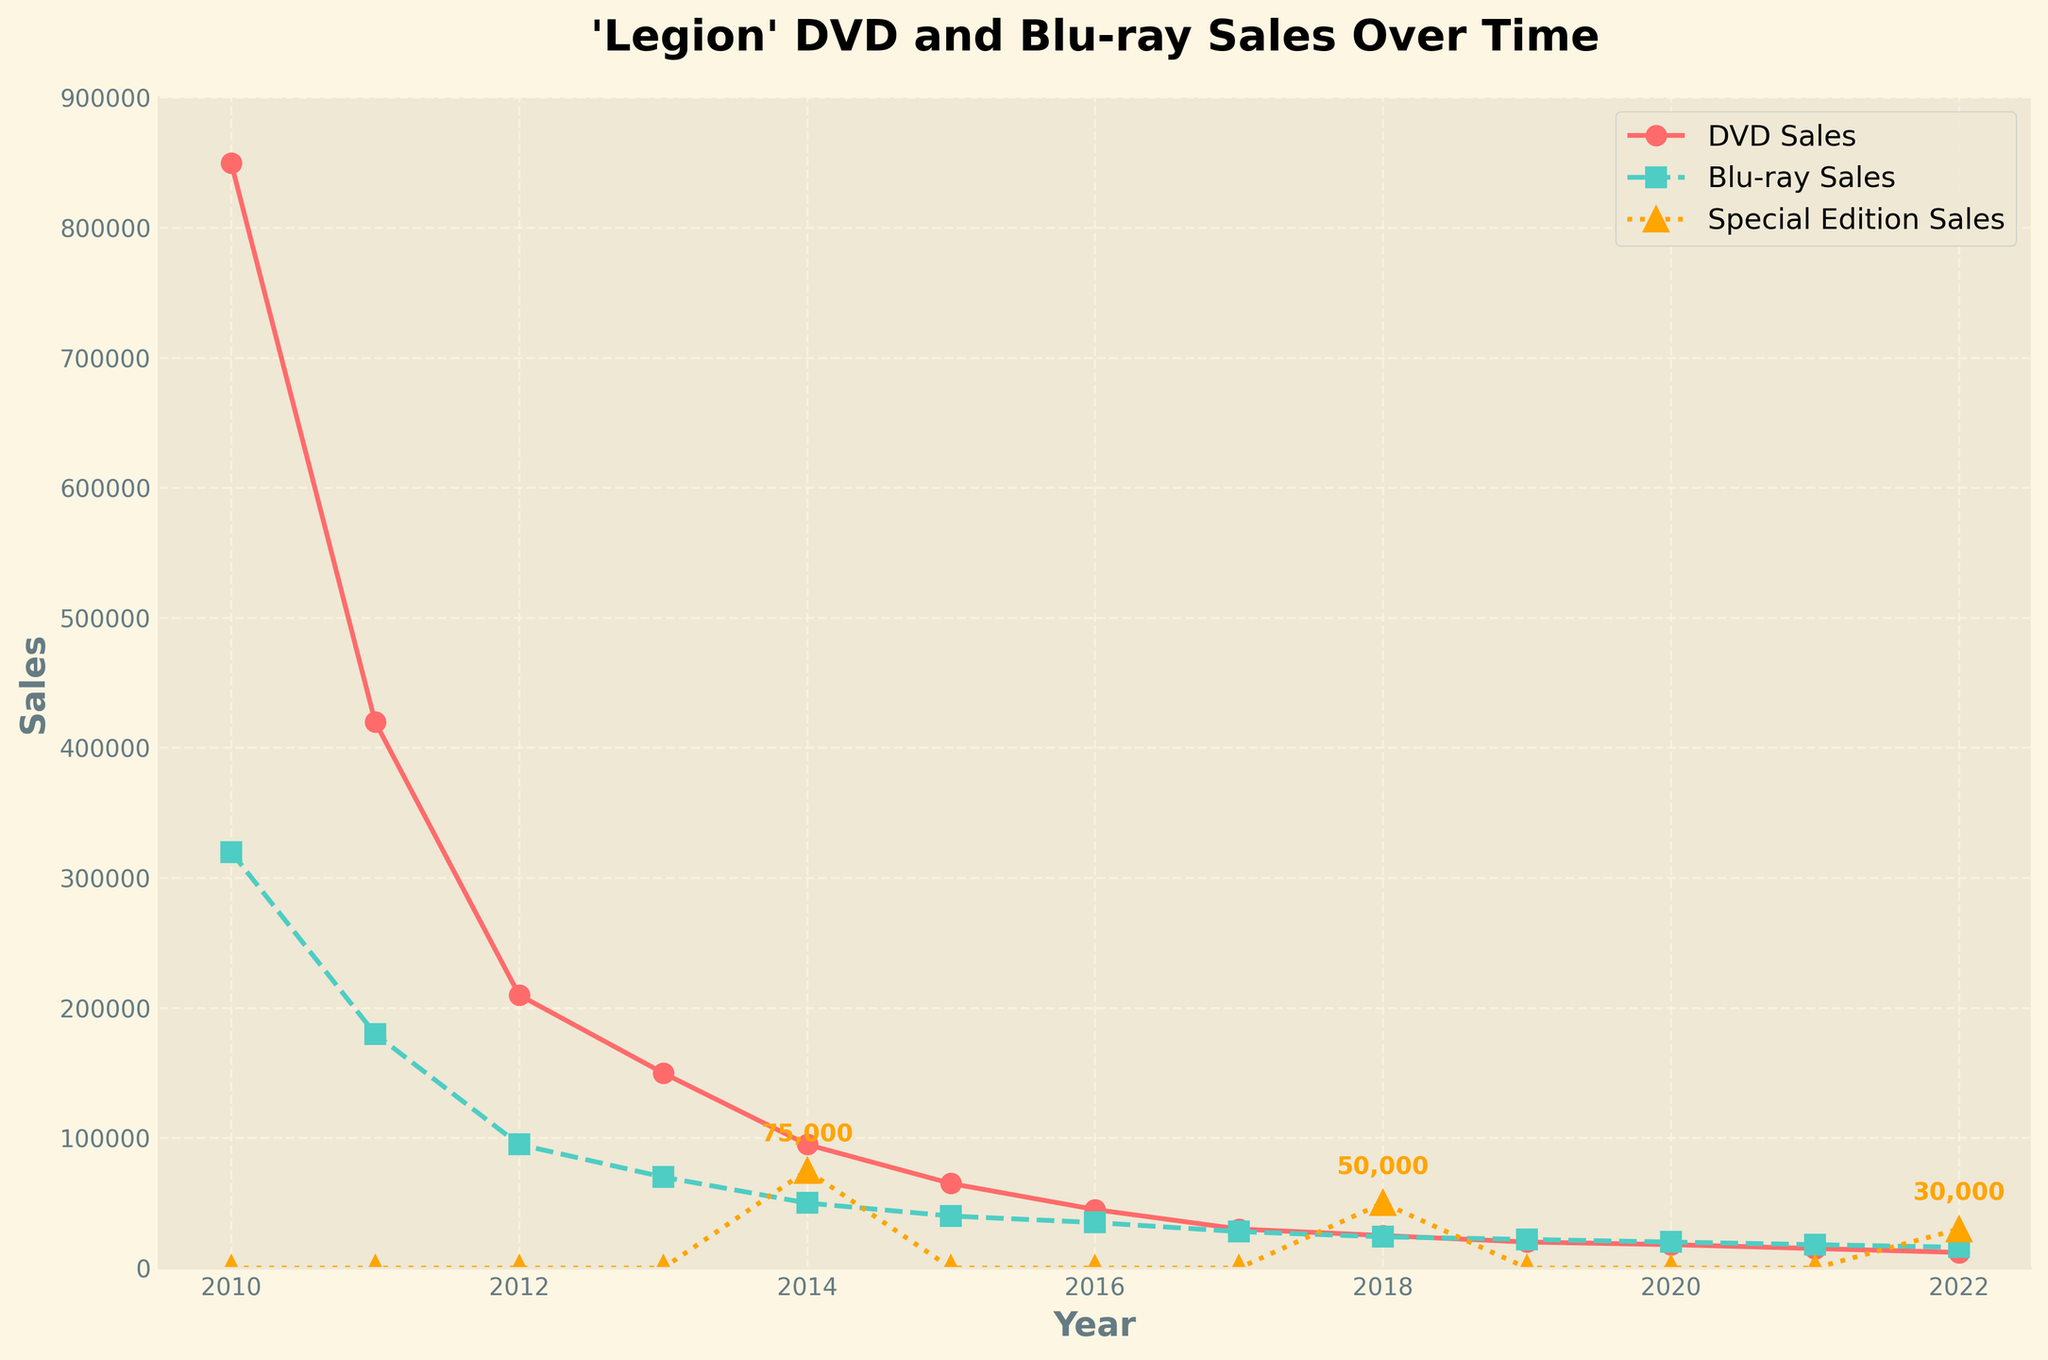what is the peak sales year for DVD sales for 'Legion'? By looking at the line chart for DVD sales, identify the year where the DVD sales marker is the highest. The red line is highest in 2010, indicating peak sales.
Answer: 2010 In which year did Blu-ray sales overtake DVD sales for the first time? Observe the point where the green Blu-ray line surpasses the red DVD sales line. Blu-ray sales first exceed DVD sales in 2020.
Answer: 2020 What is the total sales of special edition releases? Add the values of special edition sales from all years: 75,000+50,000+30,000=155,000.
Answer: 155,000 Compare DVD and Blu-ray sales in 2018 and identify which format sold more units. From the chart, DVD sales are 25,000 and Blu-ray sales are 24,000 in 2018, making DVD sales higher.
Answer: DVD In which year did both DVD and Blu-ray sales decline the most compared to the previous year? Calculate the difference in sales for each year compared to the previous year. The biggest decrease is from 2012 to 2013, with DVD sales dropping from 210,000 to 150,000 and Blu-ray from 95,000 to 70,000.
Answer: 2013 By what percentage did DVD sales decrease from 2011 to 2012? Calculate the percentage decrease: (210,000 - 420,000) / 420,000 * 100 = 50%.
Answer: 50% How do the DVD and Blu-ray sales trends differ over the years? DVD sales show a continuous decline from 2010 onwards, whereas Blu-ray sales also decline but at a slower rate with smaller fluctuations and even a slight increase in certain years.
Answer: DVD declines more rapidly How many more units of DVDs were sold than Blu-rays in 2010? Subtract Blu-ray sales from DVD sales for 2010: 850,000 - 320,000 = 530,000.
Answer: 530,000 Which year had the highest special edition sales, and what were the sales numbers? Identify the highest point on the orange special edition sales line. The highest sales, 75,000, occur in 2014.
Answer: 2014 